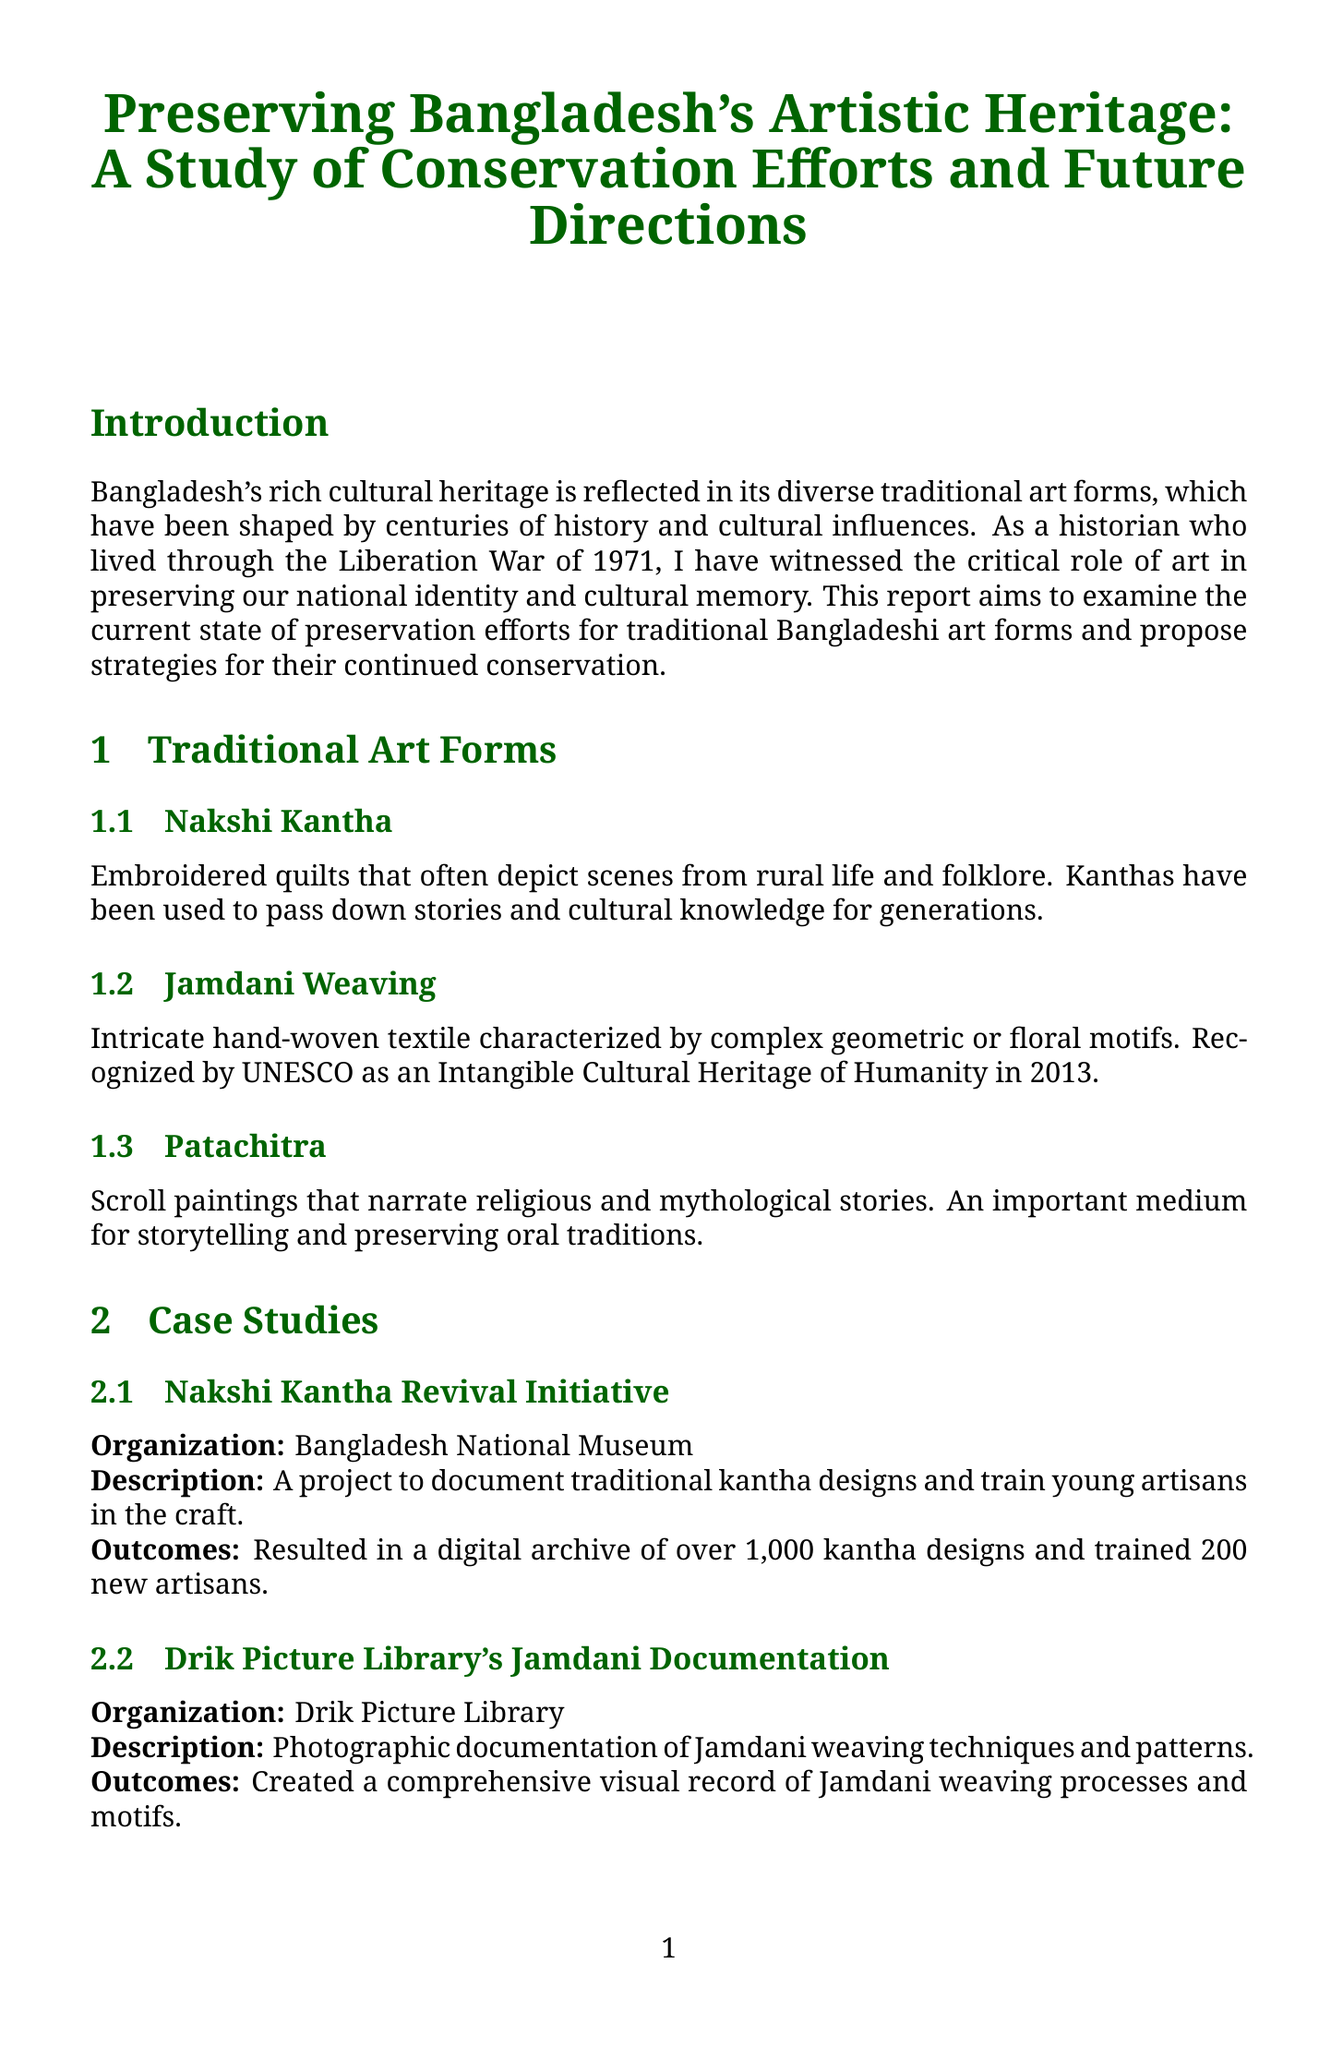what is the title of the report? The title of the report is "Preserving Bangladesh's Artistic Heritage: A Study of Conservation Efforts and Future Directions."
Answer: "Preserving Bangladesh's Artistic Heritage: A Study of Conservation Efforts and Future Directions" how many traditional art forms are discussed in the report? The report discusses three traditional art forms: Nakshi Kantha, Jamdani Weaving, and Patachitra.
Answer: 3 what organization was involved in the Nakshi Kantha Revival Initiative? The organization involved in the Nakshi Kantha Revival Initiative is the Bangladesh National Museum.
Answer: Bangladesh National Museum which traditional art form is recognized by UNESCO? The traditional art form recognized by UNESCO is Jamdani Weaving.
Answer: Jamdani Weaving what is one challenge mentioned regarding the preservation of traditional art forms? One challenge mentioned is "Lack of funding for long-term conservation projects."
Answer: Lack of funding for long-term conservation projects how many kantha designs were archived in the Nakshi Kantha Revival Initiative? The Nakshi Kantha Revival Initiative resulted in a digital archive of over 1,000 kantha designs.
Answer: over 1,000 what is one recommendation made in the report for future preservation efforts? One recommendation made is to "Establish a National Traditional Arts Council."
Answer: Establish a National Traditional Arts Council what historical significance is associated with Patachitra? Patachitra is an important medium for storytelling and preserving oral traditions.
Answer: important medium for storytelling and preserving oral traditions 